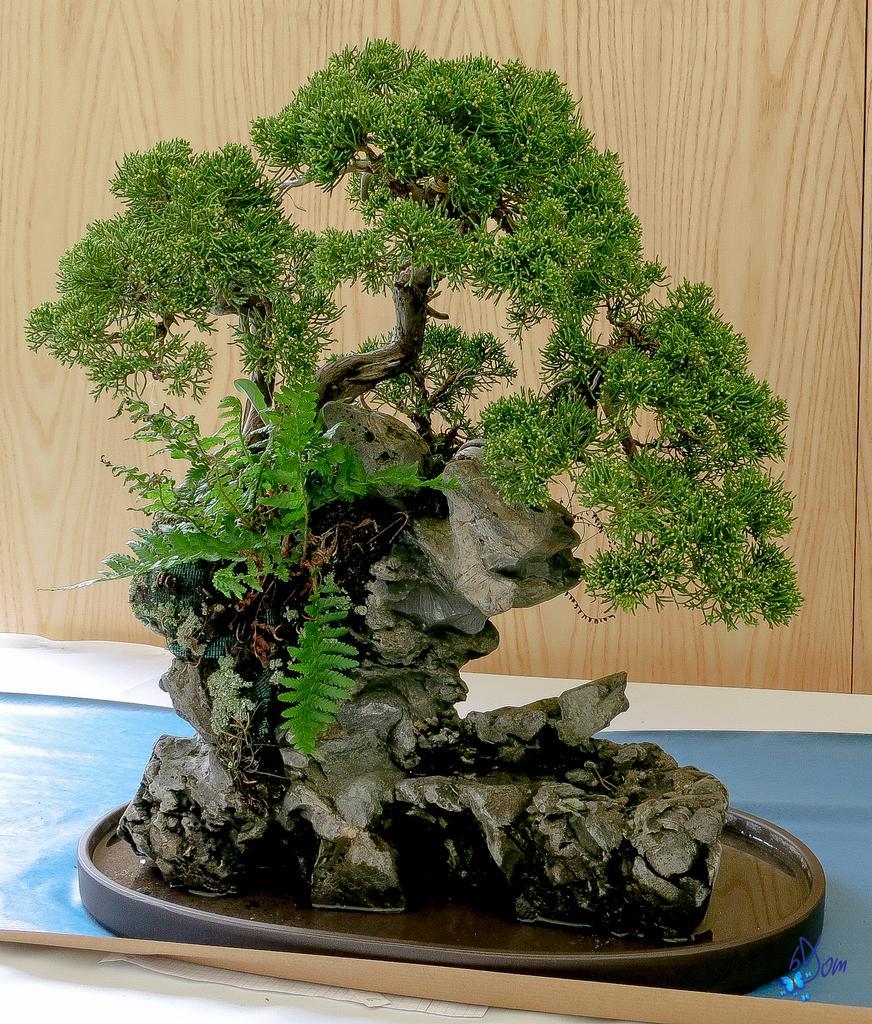How would you summarize this image in a sentence or two? In this image there is a plant on the tray with water and rock, the plant is on a table with blue colored cover, at the bottom of the image there is some text, behind the tree there is a wooden wall. 